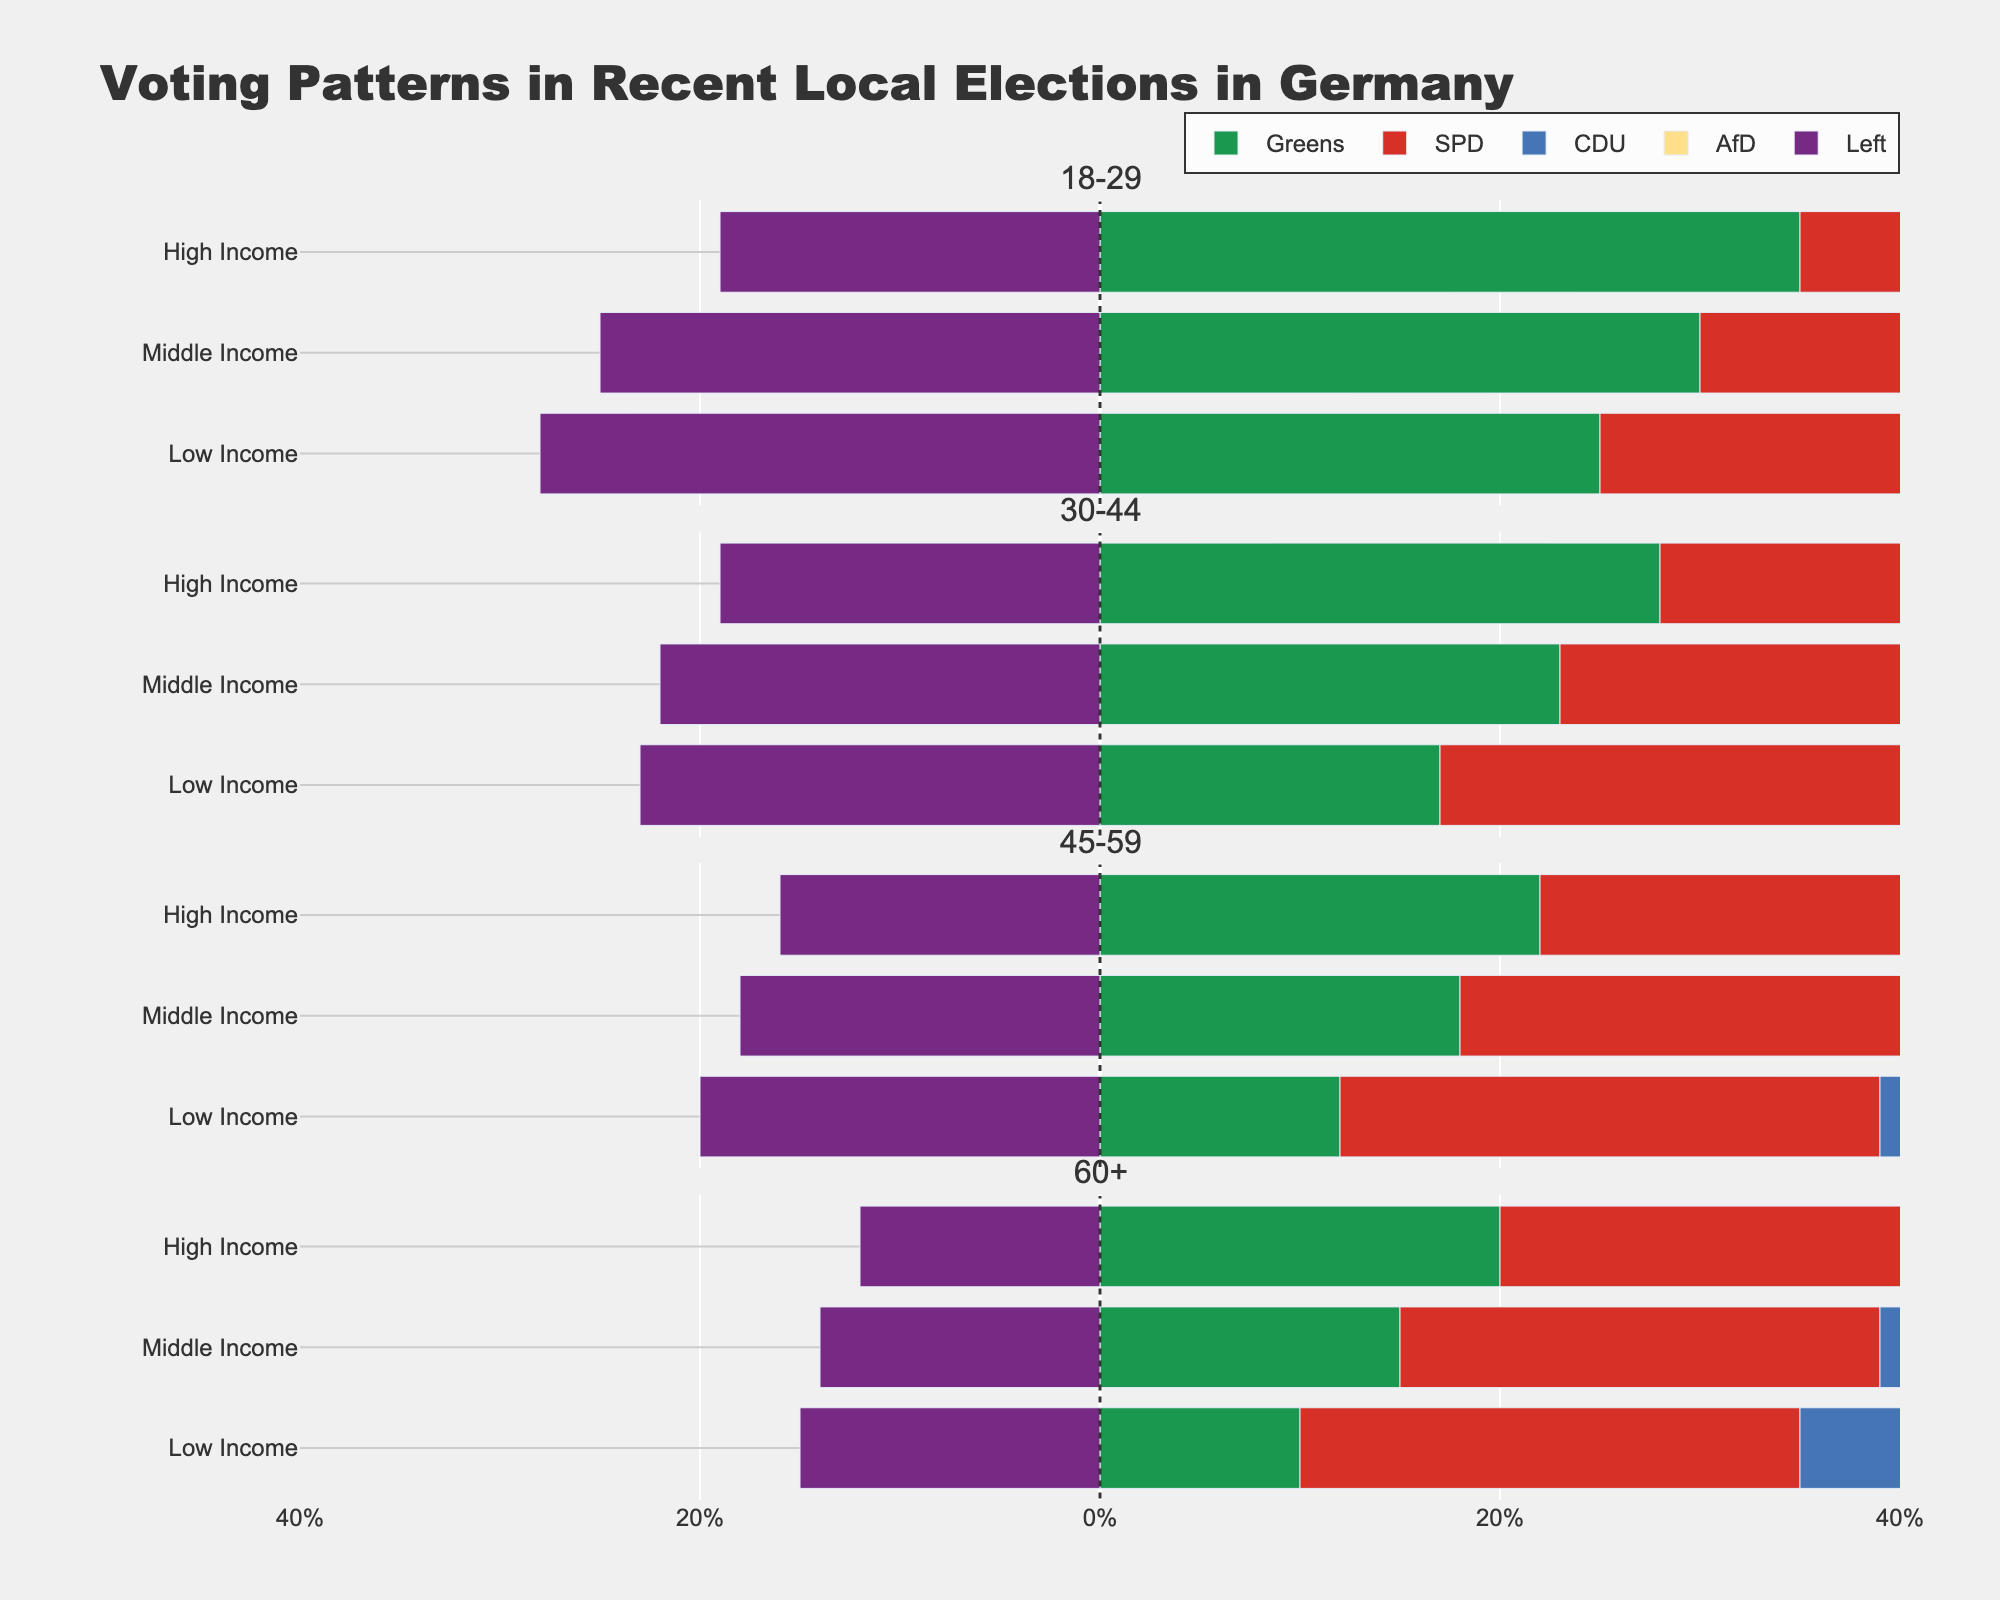What is the overall trend in the percentage of voters for the Left party as the socio-economic status increases in the 18-29 age group? Observe the horizontal bars representing the Left party (which appear in purple) for each socio-economic status in the 18-29 age group. For low income, the Left party has 28%; for middle income, it decreases slightly to 25%; and for high income, it decreases further to 19%.
Answer: The percentage of voters for the Left party decreases as socio-economic status increases in the 18-29 age group Which socio-economic status within the 30-44 age group shows the highest percentage of votes for SPD? In the 30-44 age group, look at the height of the red bars (SPD party) across low, middle, and high-income categories. Low income has 25%, middle income has 22%, and high income has 20%.
Answer: Low income Compare the voting patterns for the Greens among different socio-economic statuses within the 60+ age group. Identify the green bars in the 60+ age group for each socio-economic status. Low income has 10%, middle income has 15%, and high income has 20%.
Answer: High income has the highest percentage of votes for the Greens, followed by middle income, and then low income For the 45-59 age group, which party has the most substantial reduction in voter percentage when comparing low income to high income? Compare the differences in horizontal bars for each party from low income to high income in the 45-59 age group. Greens reduce from 12% to 22%, SPD from 27% to 22%, CDU from 23% to 30%, AfD from 18% to 10%, and Left from 20% to 16%. The AfD party has the most significant reduction from 18% to 10% (a difference of 8%).
Answer: AfD What is the overall trend in percentage votes for the AfD party across age groups for high-income status? Look at the yellow bars (AfD party) across different age groups within the high-income status. 18-29 age group has 6%, 30-44 has 8%, 45-59 has 10%, and 60+ has 12%.
Answer: The percentage votes for AfD generally increase with age for high-income status How does the voting percentage for the CDU change as age increases for middle-income voters? Compare the blue bars (CDU party) for middle-income voters across each age group. 18-29 has 18%, 30-44 has 23%, 45-59 has 27%, and 60+ has 32%.
Answer: The voting percentage for the CDU increases as age increases for middle-income voters Which age group shows the strongest support for the Left party among low-income individuals? Look at the purple bars (Left party) within low income across all age groups. 18-29 has 28%, 30-44 has 23%, 45-59 has 20%, and 60+ has 15%.
Answer: 18-29 age group Which socio-economic group in the 18-29 age group shows the lowest support for AfD? Identify the yellow bars (AfD party) in the 18-29 age group for each socio-economic status. Low income has 10%, middle income has 7%, and high income has 6%.
Answer: High income Are there any age groups where the SPD receives more than 25% of the vote in any socio-economic status? Examine the red bars (SPD party) in each age group and socio-economic status. 30-44 and 45-59 low-income groups both have SPD at 25%, neither exceeding 25%. Therefore, there is no age group where SPD receives more than 25%.
Answer: No What is the difference in voting percentage for the Greens between low-income and high-income voters within the 30-44 age group? Find the green bars (Greens party) within the 30-44 age group for low-income and high-income voters. Low income is 17% and high income is 28%. The difference is 28% - 17% = 11%.
Answer: 11% 